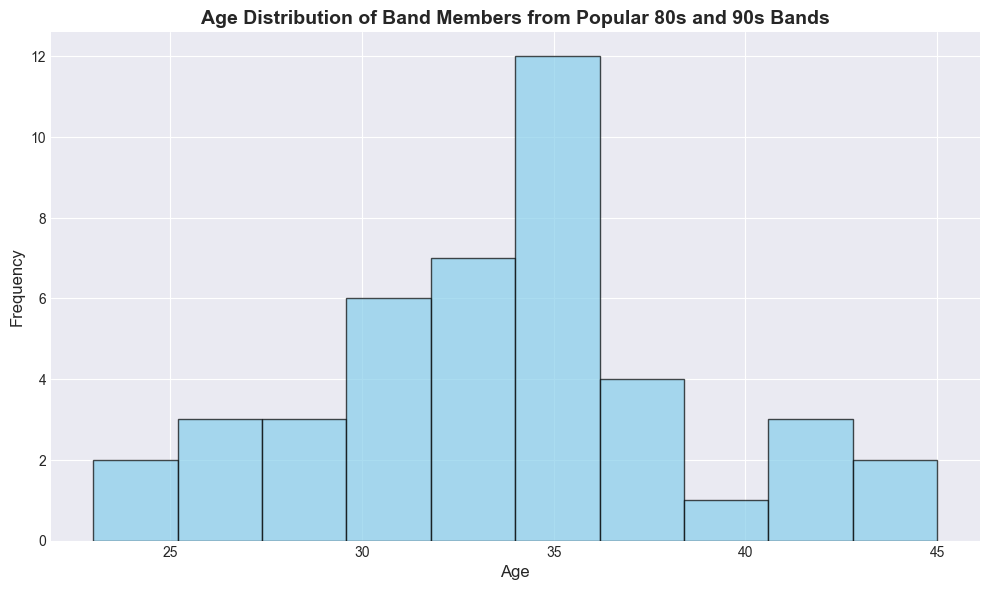How many band members are in their 30s? To determine the number of band members in their 30s, examine the histogram bin that represents ages 30-39. Count the frequency or the height of this bin to get the total number of band members in this age range.
Answer: 17 What is the most common age group of the band members? Identify the tallest bar in the histogram as it represents the most frequently occurring age group among the band members. The age range that this bar covers is the most common age group.
Answer: 30-39 Which age group has the least number of band members? Look for the shortest bar or bars in the histogram. The age range these bars cover represents the age group with the smallest number of band members.
Answer: 20-29 How does the number of band members in their 40s compare to those in their 20s? Compare the height of the bar representing ages 40-49 with the bar representing ages 20-29 in the histogram. If one bar is taller, that age group has more band members.
Answer: More in their 20s What is the average age of band members, given the data in the histogram? To calculate the average age, you need to multiply each age or midpoint of the age range by its respective frequency, sum these values, and then divide by the total number of band members.
Answer: ~33 